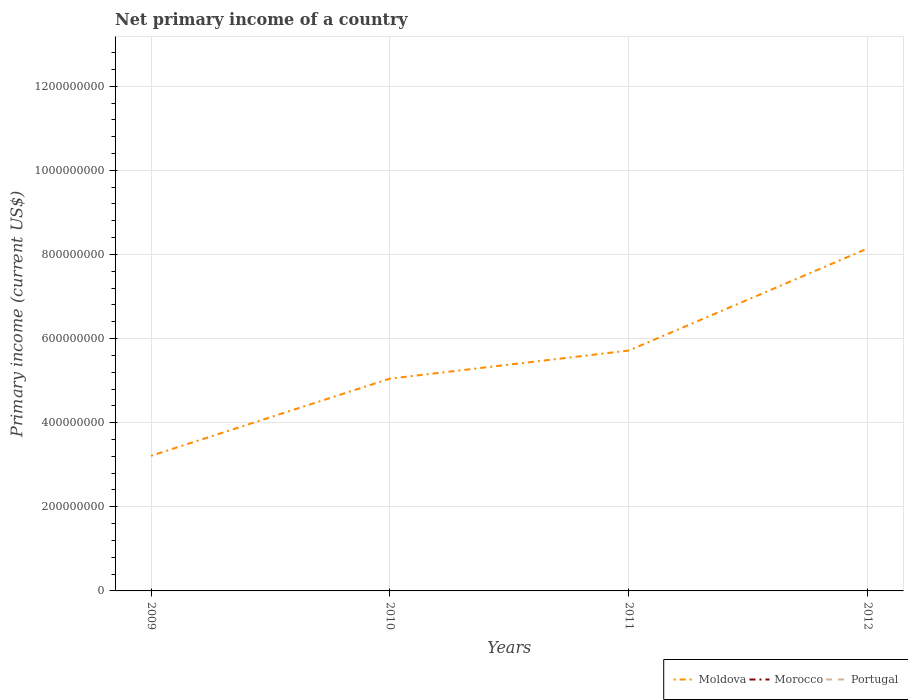Does the line corresponding to Moldova intersect with the line corresponding to Morocco?
Provide a short and direct response. No. Is the number of lines equal to the number of legend labels?
Give a very brief answer. No. What is the total primary income in Moldova in the graph?
Your response must be concise. -3.10e+08. What is the difference between the highest and the second highest primary income in Moldova?
Give a very brief answer. 4.93e+08. Is the primary income in Moldova strictly greater than the primary income in Portugal over the years?
Your answer should be very brief. No. How many lines are there?
Keep it short and to the point. 1. How many years are there in the graph?
Give a very brief answer. 4. Are the values on the major ticks of Y-axis written in scientific E-notation?
Make the answer very short. No. Does the graph contain any zero values?
Give a very brief answer. Yes. Does the graph contain grids?
Your answer should be very brief. Yes. What is the title of the graph?
Your answer should be very brief. Net primary income of a country. What is the label or title of the Y-axis?
Provide a short and direct response. Primary income (current US$). What is the Primary income (current US$) of Moldova in 2009?
Keep it short and to the point. 3.21e+08. What is the Primary income (current US$) in Morocco in 2009?
Provide a short and direct response. 0. What is the Primary income (current US$) in Moldova in 2010?
Give a very brief answer. 5.05e+08. What is the Primary income (current US$) in Portugal in 2010?
Provide a succinct answer. 0. What is the Primary income (current US$) of Moldova in 2011?
Your response must be concise. 5.72e+08. What is the Primary income (current US$) in Morocco in 2011?
Your response must be concise. 0. What is the Primary income (current US$) in Moldova in 2012?
Make the answer very short. 8.14e+08. What is the Primary income (current US$) of Morocco in 2012?
Your response must be concise. 0. Across all years, what is the maximum Primary income (current US$) of Moldova?
Offer a terse response. 8.14e+08. Across all years, what is the minimum Primary income (current US$) of Moldova?
Provide a short and direct response. 3.21e+08. What is the total Primary income (current US$) in Moldova in the graph?
Make the answer very short. 2.21e+09. What is the total Primary income (current US$) in Portugal in the graph?
Make the answer very short. 0. What is the difference between the Primary income (current US$) of Moldova in 2009 and that in 2010?
Offer a terse response. -1.83e+08. What is the difference between the Primary income (current US$) of Moldova in 2009 and that in 2011?
Provide a succinct answer. -2.50e+08. What is the difference between the Primary income (current US$) in Moldova in 2009 and that in 2012?
Make the answer very short. -4.93e+08. What is the difference between the Primary income (current US$) of Moldova in 2010 and that in 2011?
Your answer should be compact. -6.68e+07. What is the difference between the Primary income (current US$) of Moldova in 2010 and that in 2012?
Your answer should be very brief. -3.10e+08. What is the difference between the Primary income (current US$) of Moldova in 2011 and that in 2012?
Provide a short and direct response. -2.43e+08. What is the average Primary income (current US$) in Moldova per year?
Your answer should be compact. 5.53e+08. What is the average Primary income (current US$) of Morocco per year?
Make the answer very short. 0. What is the ratio of the Primary income (current US$) of Moldova in 2009 to that in 2010?
Provide a short and direct response. 0.64. What is the ratio of the Primary income (current US$) in Moldova in 2009 to that in 2011?
Provide a short and direct response. 0.56. What is the ratio of the Primary income (current US$) in Moldova in 2009 to that in 2012?
Provide a succinct answer. 0.39. What is the ratio of the Primary income (current US$) of Moldova in 2010 to that in 2011?
Offer a terse response. 0.88. What is the ratio of the Primary income (current US$) in Moldova in 2010 to that in 2012?
Your answer should be very brief. 0.62. What is the ratio of the Primary income (current US$) of Moldova in 2011 to that in 2012?
Make the answer very short. 0.7. What is the difference between the highest and the second highest Primary income (current US$) of Moldova?
Your answer should be very brief. 2.43e+08. What is the difference between the highest and the lowest Primary income (current US$) in Moldova?
Offer a terse response. 4.93e+08. 